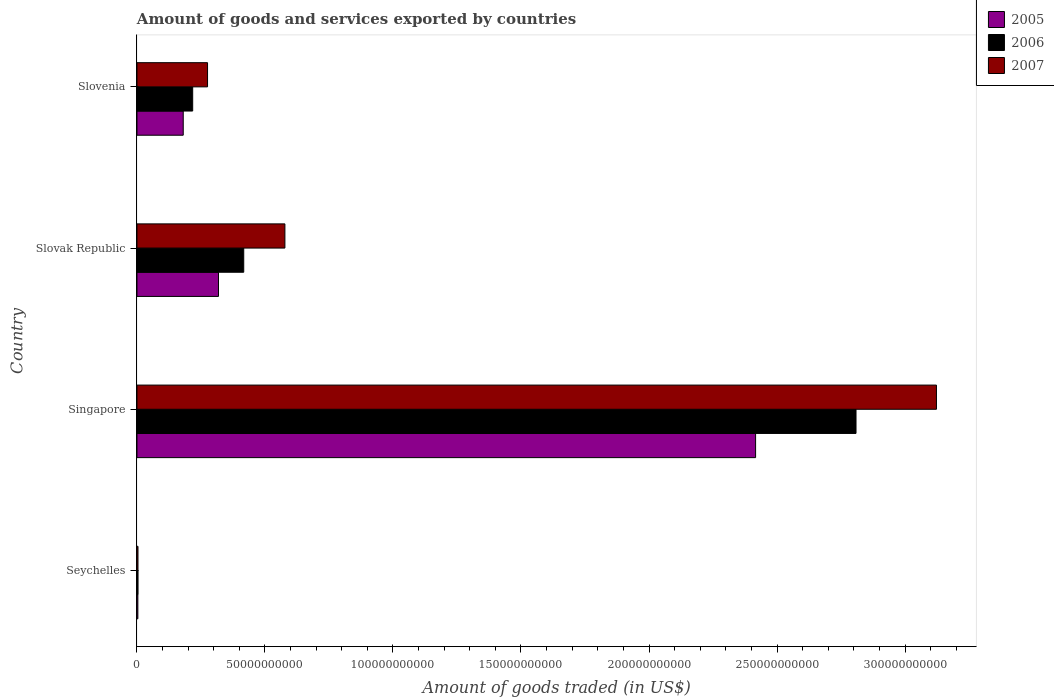Are the number of bars on each tick of the Y-axis equal?
Provide a short and direct response. Yes. How many bars are there on the 1st tick from the top?
Offer a very short reply. 3. How many bars are there on the 2nd tick from the bottom?
Make the answer very short. 3. What is the label of the 4th group of bars from the top?
Provide a short and direct response. Seychelles. In how many cases, is the number of bars for a given country not equal to the number of legend labels?
Give a very brief answer. 0. What is the total amount of goods and services exported in 2007 in Slovenia?
Provide a succinct answer. 2.76e+1. Across all countries, what is the maximum total amount of goods and services exported in 2007?
Your response must be concise. 3.12e+11. Across all countries, what is the minimum total amount of goods and services exported in 2005?
Ensure brevity in your answer.  3.50e+08. In which country was the total amount of goods and services exported in 2007 maximum?
Offer a terse response. Singapore. In which country was the total amount of goods and services exported in 2007 minimum?
Your answer should be compact. Seychelles. What is the total total amount of goods and services exported in 2006 in the graph?
Make the answer very short. 3.45e+11. What is the difference between the total amount of goods and services exported in 2006 in Slovak Republic and that in Slovenia?
Make the answer very short. 1.99e+1. What is the difference between the total amount of goods and services exported in 2005 in Singapore and the total amount of goods and services exported in 2007 in Seychelles?
Your answer should be very brief. 2.41e+11. What is the average total amount of goods and services exported in 2006 per country?
Keep it short and to the point. 8.62e+1. What is the difference between the total amount of goods and services exported in 2007 and total amount of goods and services exported in 2006 in Singapore?
Provide a succinct answer. 3.14e+1. In how many countries, is the total amount of goods and services exported in 2005 greater than 270000000000 US$?
Provide a short and direct response. 0. What is the ratio of the total amount of goods and services exported in 2005 in Seychelles to that in Slovak Republic?
Offer a very short reply. 0.01. Is the total amount of goods and services exported in 2007 in Singapore less than that in Slovenia?
Give a very brief answer. No. What is the difference between the highest and the second highest total amount of goods and services exported in 2006?
Provide a succinct answer. 2.39e+11. What is the difference between the highest and the lowest total amount of goods and services exported in 2006?
Offer a terse response. 2.80e+11. What does the 3rd bar from the top in Slovak Republic represents?
Ensure brevity in your answer.  2005. What does the 1st bar from the bottom in Seychelles represents?
Give a very brief answer. 2005. How many bars are there?
Your answer should be very brief. 12. Are all the bars in the graph horizontal?
Give a very brief answer. Yes. What is the difference between two consecutive major ticks on the X-axis?
Your answer should be compact. 5.00e+1. Does the graph contain grids?
Offer a very short reply. No. Where does the legend appear in the graph?
Provide a short and direct response. Top right. How many legend labels are there?
Provide a short and direct response. 3. How are the legend labels stacked?
Provide a short and direct response. Vertical. What is the title of the graph?
Give a very brief answer. Amount of goods and services exported by countries. What is the label or title of the X-axis?
Your response must be concise. Amount of goods traded (in US$). What is the Amount of goods traded (in US$) in 2005 in Seychelles?
Your response must be concise. 3.50e+08. What is the Amount of goods traded (in US$) of 2006 in Seychelles?
Keep it short and to the point. 4.19e+08. What is the Amount of goods traded (in US$) in 2007 in Seychelles?
Give a very brief answer. 3.98e+08. What is the Amount of goods traded (in US$) of 2005 in Singapore?
Provide a short and direct response. 2.42e+11. What is the Amount of goods traded (in US$) in 2006 in Singapore?
Provide a short and direct response. 2.81e+11. What is the Amount of goods traded (in US$) of 2007 in Singapore?
Give a very brief answer. 3.12e+11. What is the Amount of goods traded (in US$) in 2005 in Slovak Republic?
Provide a succinct answer. 3.18e+1. What is the Amount of goods traded (in US$) in 2006 in Slovak Republic?
Give a very brief answer. 4.17e+1. What is the Amount of goods traded (in US$) in 2007 in Slovak Republic?
Your response must be concise. 5.78e+1. What is the Amount of goods traded (in US$) of 2005 in Slovenia?
Keep it short and to the point. 1.81e+1. What is the Amount of goods traded (in US$) of 2006 in Slovenia?
Your answer should be compact. 2.18e+1. What is the Amount of goods traded (in US$) in 2007 in Slovenia?
Provide a succinct answer. 2.76e+1. Across all countries, what is the maximum Amount of goods traded (in US$) in 2005?
Your response must be concise. 2.42e+11. Across all countries, what is the maximum Amount of goods traded (in US$) of 2006?
Make the answer very short. 2.81e+11. Across all countries, what is the maximum Amount of goods traded (in US$) of 2007?
Your response must be concise. 3.12e+11. Across all countries, what is the minimum Amount of goods traded (in US$) in 2005?
Offer a terse response. 3.50e+08. Across all countries, what is the minimum Amount of goods traded (in US$) in 2006?
Give a very brief answer. 4.19e+08. Across all countries, what is the minimum Amount of goods traded (in US$) in 2007?
Offer a very short reply. 3.98e+08. What is the total Amount of goods traded (in US$) in 2005 in the graph?
Ensure brevity in your answer.  2.92e+11. What is the total Amount of goods traded (in US$) in 2006 in the graph?
Your answer should be very brief. 3.45e+11. What is the total Amount of goods traded (in US$) of 2007 in the graph?
Your answer should be very brief. 3.98e+11. What is the difference between the Amount of goods traded (in US$) of 2005 in Seychelles and that in Singapore?
Make the answer very short. -2.41e+11. What is the difference between the Amount of goods traded (in US$) in 2006 in Seychelles and that in Singapore?
Make the answer very short. -2.80e+11. What is the difference between the Amount of goods traded (in US$) of 2007 in Seychelles and that in Singapore?
Provide a succinct answer. -3.12e+11. What is the difference between the Amount of goods traded (in US$) of 2005 in Seychelles and that in Slovak Republic?
Provide a succinct answer. -3.15e+1. What is the difference between the Amount of goods traded (in US$) in 2006 in Seychelles and that in Slovak Republic?
Give a very brief answer. -4.13e+1. What is the difference between the Amount of goods traded (in US$) in 2007 in Seychelles and that in Slovak Republic?
Your answer should be very brief. -5.74e+1. What is the difference between the Amount of goods traded (in US$) in 2005 in Seychelles and that in Slovenia?
Provide a short and direct response. -1.77e+1. What is the difference between the Amount of goods traded (in US$) in 2006 in Seychelles and that in Slovenia?
Your response must be concise. -2.13e+1. What is the difference between the Amount of goods traded (in US$) of 2007 in Seychelles and that in Slovenia?
Offer a very short reply. -2.72e+1. What is the difference between the Amount of goods traded (in US$) of 2005 in Singapore and that in Slovak Republic?
Your answer should be compact. 2.10e+11. What is the difference between the Amount of goods traded (in US$) of 2006 in Singapore and that in Slovak Republic?
Provide a short and direct response. 2.39e+11. What is the difference between the Amount of goods traded (in US$) in 2007 in Singapore and that in Slovak Republic?
Your answer should be compact. 2.54e+11. What is the difference between the Amount of goods traded (in US$) in 2005 in Singapore and that in Slovenia?
Offer a terse response. 2.24e+11. What is the difference between the Amount of goods traded (in US$) of 2006 in Singapore and that in Slovenia?
Offer a very short reply. 2.59e+11. What is the difference between the Amount of goods traded (in US$) in 2007 in Singapore and that in Slovenia?
Ensure brevity in your answer.  2.85e+11. What is the difference between the Amount of goods traded (in US$) in 2005 in Slovak Republic and that in Slovenia?
Give a very brief answer. 1.38e+1. What is the difference between the Amount of goods traded (in US$) of 2006 in Slovak Republic and that in Slovenia?
Provide a succinct answer. 1.99e+1. What is the difference between the Amount of goods traded (in US$) of 2007 in Slovak Republic and that in Slovenia?
Ensure brevity in your answer.  3.02e+1. What is the difference between the Amount of goods traded (in US$) in 2005 in Seychelles and the Amount of goods traded (in US$) in 2006 in Singapore?
Give a very brief answer. -2.81e+11. What is the difference between the Amount of goods traded (in US$) of 2005 in Seychelles and the Amount of goods traded (in US$) of 2007 in Singapore?
Give a very brief answer. -3.12e+11. What is the difference between the Amount of goods traded (in US$) of 2006 in Seychelles and the Amount of goods traded (in US$) of 2007 in Singapore?
Your answer should be very brief. -3.12e+11. What is the difference between the Amount of goods traded (in US$) in 2005 in Seychelles and the Amount of goods traded (in US$) in 2006 in Slovak Republic?
Provide a short and direct response. -4.14e+1. What is the difference between the Amount of goods traded (in US$) of 2005 in Seychelles and the Amount of goods traded (in US$) of 2007 in Slovak Republic?
Offer a terse response. -5.74e+1. What is the difference between the Amount of goods traded (in US$) in 2006 in Seychelles and the Amount of goods traded (in US$) in 2007 in Slovak Republic?
Offer a very short reply. -5.74e+1. What is the difference between the Amount of goods traded (in US$) of 2005 in Seychelles and the Amount of goods traded (in US$) of 2006 in Slovenia?
Give a very brief answer. -2.14e+1. What is the difference between the Amount of goods traded (in US$) in 2005 in Seychelles and the Amount of goods traded (in US$) in 2007 in Slovenia?
Offer a very short reply. -2.72e+1. What is the difference between the Amount of goods traded (in US$) of 2006 in Seychelles and the Amount of goods traded (in US$) of 2007 in Slovenia?
Your answer should be very brief. -2.72e+1. What is the difference between the Amount of goods traded (in US$) in 2005 in Singapore and the Amount of goods traded (in US$) in 2006 in Slovak Republic?
Make the answer very short. 2.00e+11. What is the difference between the Amount of goods traded (in US$) of 2005 in Singapore and the Amount of goods traded (in US$) of 2007 in Slovak Republic?
Your answer should be compact. 1.84e+11. What is the difference between the Amount of goods traded (in US$) in 2006 in Singapore and the Amount of goods traded (in US$) in 2007 in Slovak Republic?
Offer a terse response. 2.23e+11. What is the difference between the Amount of goods traded (in US$) of 2005 in Singapore and the Amount of goods traded (in US$) of 2006 in Slovenia?
Give a very brief answer. 2.20e+11. What is the difference between the Amount of goods traded (in US$) in 2005 in Singapore and the Amount of goods traded (in US$) in 2007 in Slovenia?
Provide a short and direct response. 2.14e+11. What is the difference between the Amount of goods traded (in US$) of 2006 in Singapore and the Amount of goods traded (in US$) of 2007 in Slovenia?
Make the answer very short. 2.53e+11. What is the difference between the Amount of goods traded (in US$) in 2005 in Slovak Republic and the Amount of goods traded (in US$) in 2006 in Slovenia?
Keep it short and to the point. 1.01e+1. What is the difference between the Amount of goods traded (in US$) in 2005 in Slovak Republic and the Amount of goods traded (in US$) in 2007 in Slovenia?
Provide a short and direct response. 4.27e+09. What is the difference between the Amount of goods traded (in US$) in 2006 in Slovak Republic and the Amount of goods traded (in US$) in 2007 in Slovenia?
Offer a terse response. 1.41e+1. What is the average Amount of goods traded (in US$) of 2005 per country?
Keep it short and to the point. 7.30e+1. What is the average Amount of goods traded (in US$) of 2006 per country?
Make the answer very short. 8.62e+1. What is the average Amount of goods traded (in US$) in 2007 per country?
Provide a succinct answer. 9.95e+1. What is the difference between the Amount of goods traded (in US$) of 2005 and Amount of goods traded (in US$) of 2006 in Seychelles?
Your response must be concise. -6.91e+07. What is the difference between the Amount of goods traded (in US$) in 2005 and Amount of goods traded (in US$) in 2007 in Seychelles?
Keep it short and to the point. -4.75e+07. What is the difference between the Amount of goods traded (in US$) in 2006 and Amount of goods traded (in US$) in 2007 in Seychelles?
Your response must be concise. 2.16e+07. What is the difference between the Amount of goods traded (in US$) in 2005 and Amount of goods traded (in US$) in 2006 in Singapore?
Your answer should be very brief. -3.92e+1. What is the difference between the Amount of goods traded (in US$) of 2005 and Amount of goods traded (in US$) of 2007 in Singapore?
Keep it short and to the point. -7.06e+1. What is the difference between the Amount of goods traded (in US$) of 2006 and Amount of goods traded (in US$) of 2007 in Singapore?
Provide a succinct answer. -3.14e+1. What is the difference between the Amount of goods traded (in US$) in 2005 and Amount of goods traded (in US$) in 2006 in Slovak Republic?
Ensure brevity in your answer.  -9.86e+09. What is the difference between the Amount of goods traded (in US$) of 2005 and Amount of goods traded (in US$) of 2007 in Slovak Republic?
Your answer should be compact. -2.59e+1. What is the difference between the Amount of goods traded (in US$) in 2006 and Amount of goods traded (in US$) in 2007 in Slovak Republic?
Provide a short and direct response. -1.61e+1. What is the difference between the Amount of goods traded (in US$) in 2005 and Amount of goods traded (in US$) in 2006 in Slovenia?
Ensure brevity in your answer.  -3.69e+09. What is the difference between the Amount of goods traded (in US$) of 2005 and Amount of goods traded (in US$) of 2007 in Slovenia?
Make the answer very short. -9.50e+09. What is the difference between the Amount of goods traded (in US$) in 2006 and Amount of goods traded (in US$) in 2007 in Slovenia?
Ensure brevity in your answer.  -5.81e+09. What is the ratio of the Amount of goods traded (in US$) of 2005 in Seychelles to that in Singapore?
Your answer should be compact. 0. What is the ratio of the Amount of goods traded (in US$) of 2006 in Seychelles to that in Singapore?
Offer a terse response. 0. What is the ratio of the Amount of goods traded (in US$) of 2007 in Seychelles to that in Singapore?
Your answer should be compact. 0. What is the ratio of the Amount of goods traded (in US$) of 2005 in Seychelles to that in Slovak Republic?
Provide a short and direct response. 0.01. What is the ratio of the Amount of goods traded (in US$) in 2006 in Seychelles to that in Slovak Republic?
Your answer should be compact. 0.01. What is the ratio of the Amount of goods traded (in US$) of 2007 in Seychelles to that in Slovak Republic?
Offer a terse response. 0.01. What is the ratio of the Amount of goods traded (in US$) of 2005 in Seychelles to that in Slovenia?
Offer a terse response. 0.02. What is the ratio of the Amount of goods traded (in US$) of 2006 in Seychelles to that in Slovenia?
Ensure brevity in your answer.  0.02. What is the ratio of the Amount of goods traded (in US$) of 2007 in Seychelles to that in Slovenia?
Make the answer very short. 0.01. What is the ratio of the Amount of goods traded (in US$) of 2005 in Singapore to that in Slovak Republic?
Give a very brief answer. 7.59. What is the ratio of the Amount of goods traded (in US$) of 2006 in Singapore to that in Slovak Republic?
Make the answer very short. 6.73. What is the ratio of the Amount of goods traded (in US$) in 2007 in Singapore to that in Slovak Republic?
Provide a short and direct response. 5.4. What is the ratio of the Amount of goods traded (in US$) in 2005 in Singapore to that in Slovenia?
Make the answer very short. 13.37. What is the ratio of the Amount of goods traded (in US$) in 2006 in Singapore to that in Slovenia?
Your response must be concise. 12.9. What is the ratio of the Amount of goods traded (in US$) in 2007 in Singapore to that in Slovenia?
Your answer should be compact. 11.33. What is the ratio of the Amount of goods traded (in US$) of 2005 in Slovak Republic to that in Slovenia?
Provide a succinct answer. 1.76. What is the ratio of the Amount of goods traded (in US$) in 2006 in Slovak Republic to that in Slovenia?
Provide a succinct answer. 1.92. What is the ratio of the Amount of goods traded (in US$) of 2007 in Slovak Republic to that in Slovenia?
Ensure brevity in your answer.  2.1. What is the difference between the highest and the second highest Amount of goods traded (in US$) in 2005?
Your answer should be very brief. 2.10e+11. What is the difference between the highest and the second highest Amount of goods traded (in US$) of 2006?
Offer a terse response. 2.39e+11. What is the difference between the highest and the second highest Amount of goods traded (in US$) in 2007?
Your response must be concise. 2.54e+11. What is the difference between the highest and the lowest Amount of goods traded (in US$) of 2005?
Your response must be concise. 2.41e+11. What is the difference between the highest and the lowest Amount of goods traded (in US$) of 2006?
Ensure brevity in your answer.  2.80e+11. What is the difference between the highest and the lowest Amount of goods traded (in US$) in 2007?
Offer a terse response. 3.12e+11. 